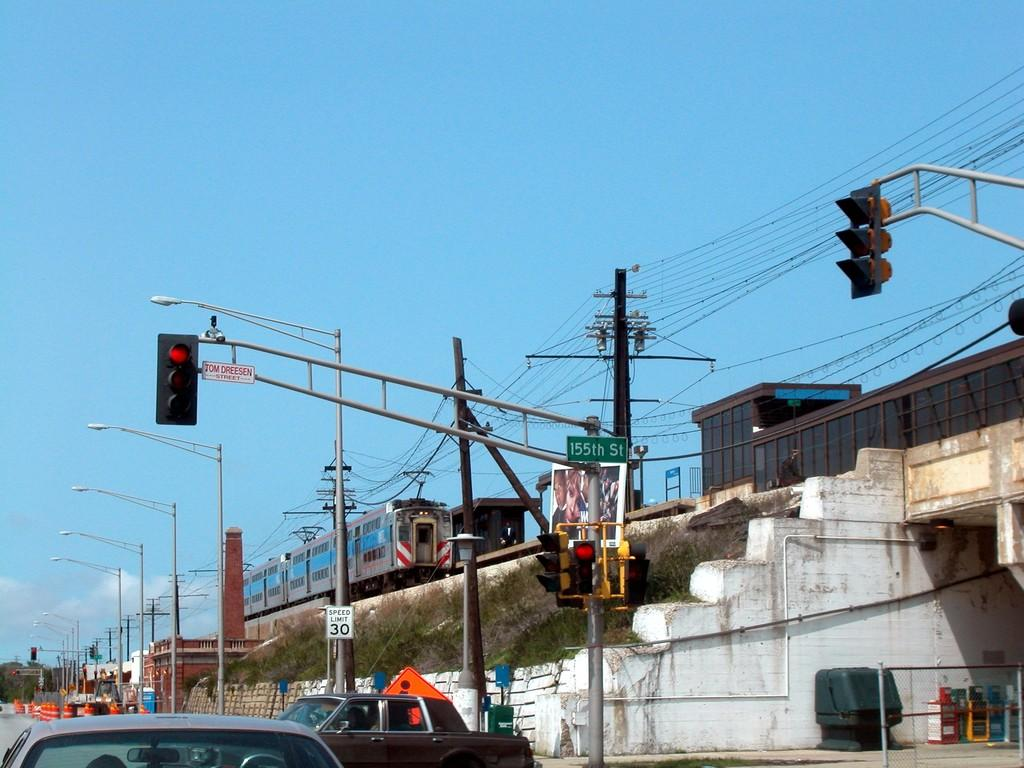Provide a one-sentence caption for the provided image. The streetlights at 155th street are turned red. 